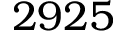Convert formula to latex. <formula><loc_0><loc_0><loc_500><loc_500>2 9 2 5</formula> 